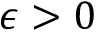<formula> <loc_0><loc_0><loc_500><loc_500>\epsilon > 0</formula> 